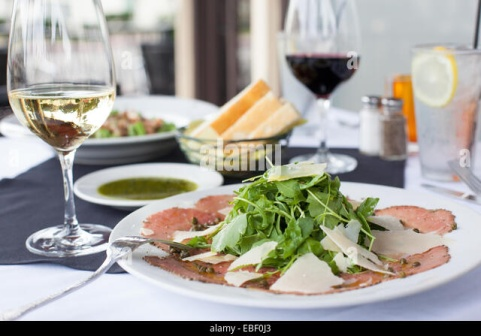Imagine the unexpected! What if this table setting had something unusual, like a tiny magical creature hiding among the arugula? Describe it. In a whimsical twist, nestled among the arugula and shaved parmesan, there's a tiny, mischievous fairy. Barely a few inches tall, with shimmering wings that sparkle like the morning dew, this magical creature keeps itself hidden from the ordinary eye. The fairy, with a dress woven from the petals of tiny flowers, peers curiously at the surrounding scene with eyes that flicker like emeralds. Occasionally, it flits to the wine glasses, inspecting the ruby liquid with an inquisitive tilt of the head, and then darts back to its leafy haven. The fairy's presence goes unnoticed, except for a subtle shimmer that could easily be mistaken for a glint of light on the plate. This magical addition brings an enchanting charm to the otherwise ordinary meal, turning the dining experience into a tale of wonder and unseen magic. 